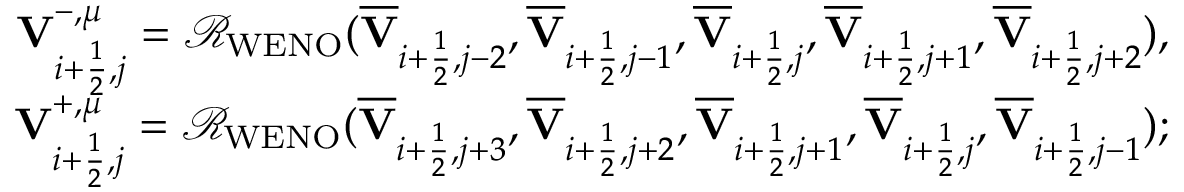Convert formula to latex. <formula><loc_0><loc_0><loc_500><loc_500>\begin{array} { r } { { V } _ { i + \frac { 1 } { 2 } , j } ^ { - , \mu } = \mathcal { R } _ { W E N O } ( \overline { V } _ { i + \frac { 1 } { 2 } , j - 2 } , \overline { V } _ { i + \frac { 1 } { 2 } , j - 1 } , \overline { V } _ { i + \frac { 1 } { 2 } , j } , \overline { V } _ { i + \frac { 1 } { 2 } , j + 1 } , \overline { V } _ { i + \frac { 1 } { 2 } , j + 2 } ) , } \\ { { V } _ { i + \frac { 1 } { 2 } , j } ^ { + , \mu } = \mathcal { R } _ { W E N O } ( \overline { V } _ { i + \frac { 1 } { 2 } , j + 3 } , \overline { V } _ { i + \frac { 1 } { 2 } , j + 2 } , \overline { V } _ { i + \frac { 1 } { 2 } , j + 1 } , \overline { V } _ { i + \frac { 1 } { 2 } , j } , \overline { V } _ { i + \frac { 1 } { 2 } , j - 1 } ) ; } \end{array}</formula> 